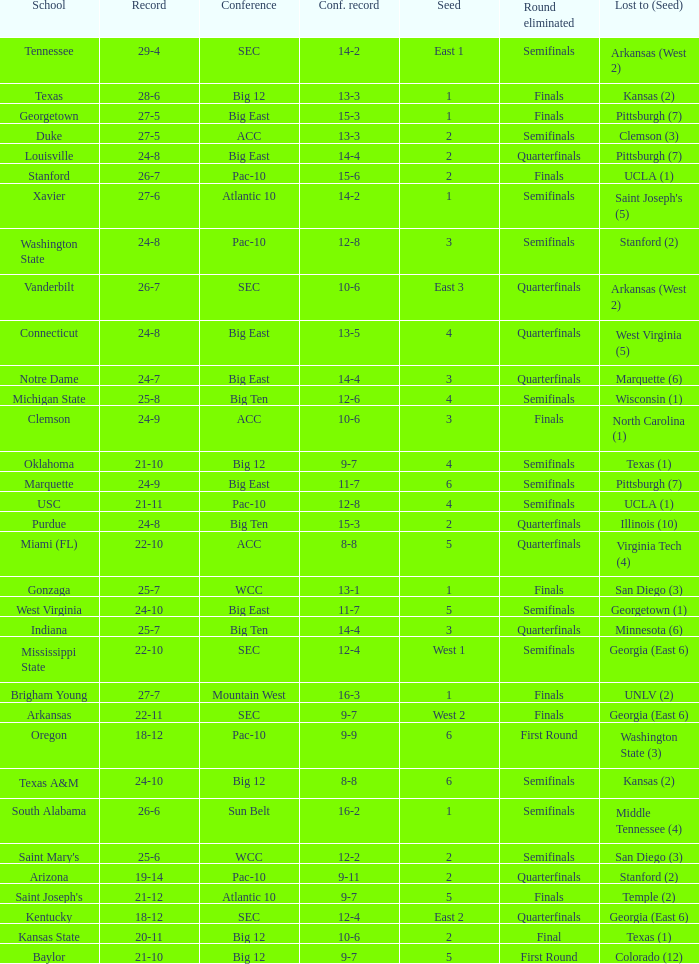Name the conference record where seed is 3 and record is 24-9 10-6. 